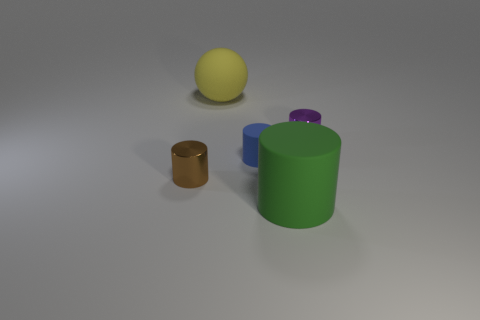There is a green thing; how many metallic objects are on the left side of it?
Your answer should be compact. 1. Are there any small gray cylinders that have the same material as the big green object?
Keep it short and to the point. No. There is a brown cylinder that is the same size as the purple object; what is it made of?
Provide a short and direct response. Metal. There is a rubber thing that is behind the green thing and in front of the small purple cylinder; how big is it?
Your response must be concise. Small. There is a thing that is both left of the blue cylinder and in front of the tiny blue thing; what color is it?
Ensure brevity in your answer.  Brown. Are there fewer green objects in front of the tiny blue rubber thing than blue rubber things to the left of the tiny brown thing?
Offer a very short reply. No. What number of large yellow objects are the same shape as the brown shiny object?
Offer a terse response. 0. What size is the ball that is the same material as the large green cylinder?
Provide a succinct answer. Large. There is a big thing behind the large rubber object that is in front of the yellow matte object; what is its color?
Give a very brief answer. Yellow. There is a tiny purple metal thing; does it have the same shape as the big rubber thing that is behind the tiny blue object?
Ensure brevity in your answer.  No. 